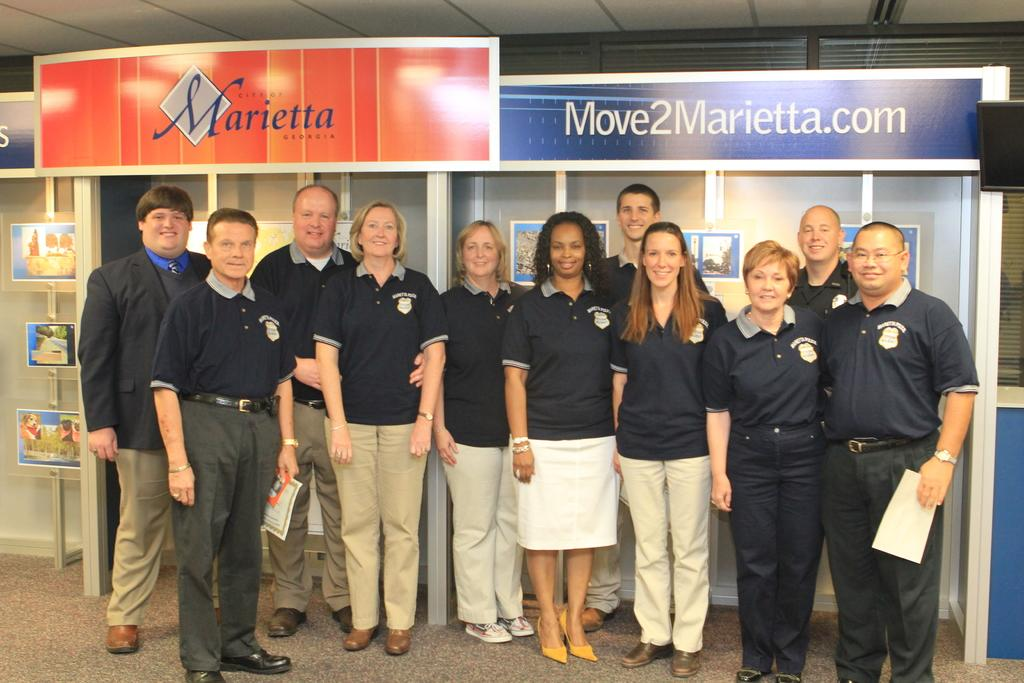What are the people in the image doing? The people in the image are standing and smiling. Can you describe any specific actions or objects held by the people? One person is holding a paper. What can be seen in the background of the image? There are boards and a television visible in the background. What type of voyage is the toad embarking on in the image? There is no toad present in the image, so it is not possible to discuss any voyage. 